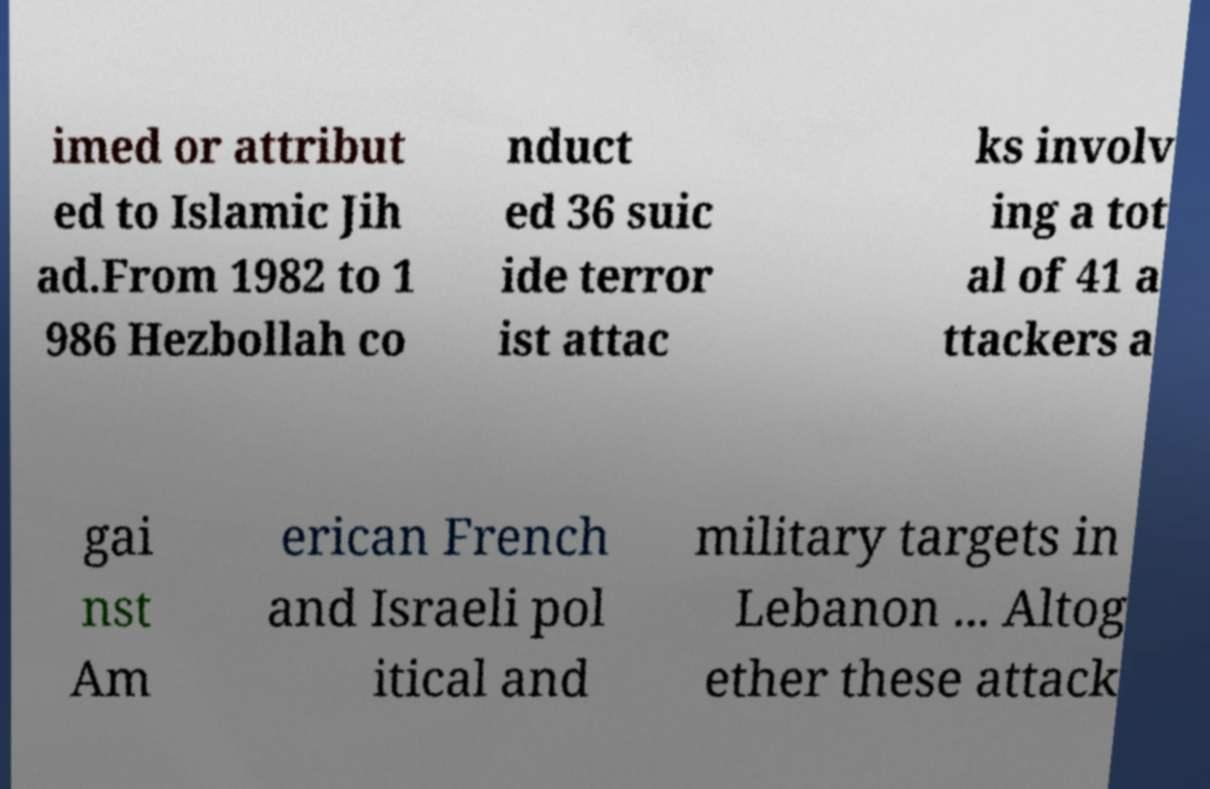What messages or text are displayed in this image? I need them in a readable, typed format. imed or attribut ed to Islamic Jih ad.From 1982 to 1 986 Hezbollah co nduct ed 36 suic ide terror ist attac ks involv ing a tot al of 41 a ttackers a gai nst Am erican French and Israeli pol itical and military targets in Lebanon ... Altog ether these attack 